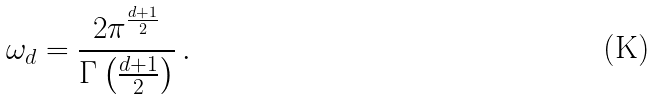<formula> <loc_0><loc_0><loc_500><loc_500>\omega _ { d } = \frac { 2 \pi ^ { \frac { d + 1 } { 2 } } } { \Gamma \left ( \frac { d + 1 } { 2 } \right ) } \, .</formula> 